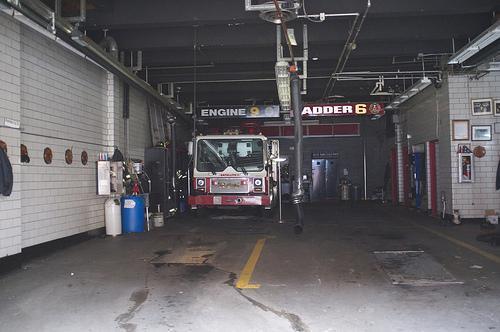How many vehicles are shown?
Give a very brief answer. 1. 